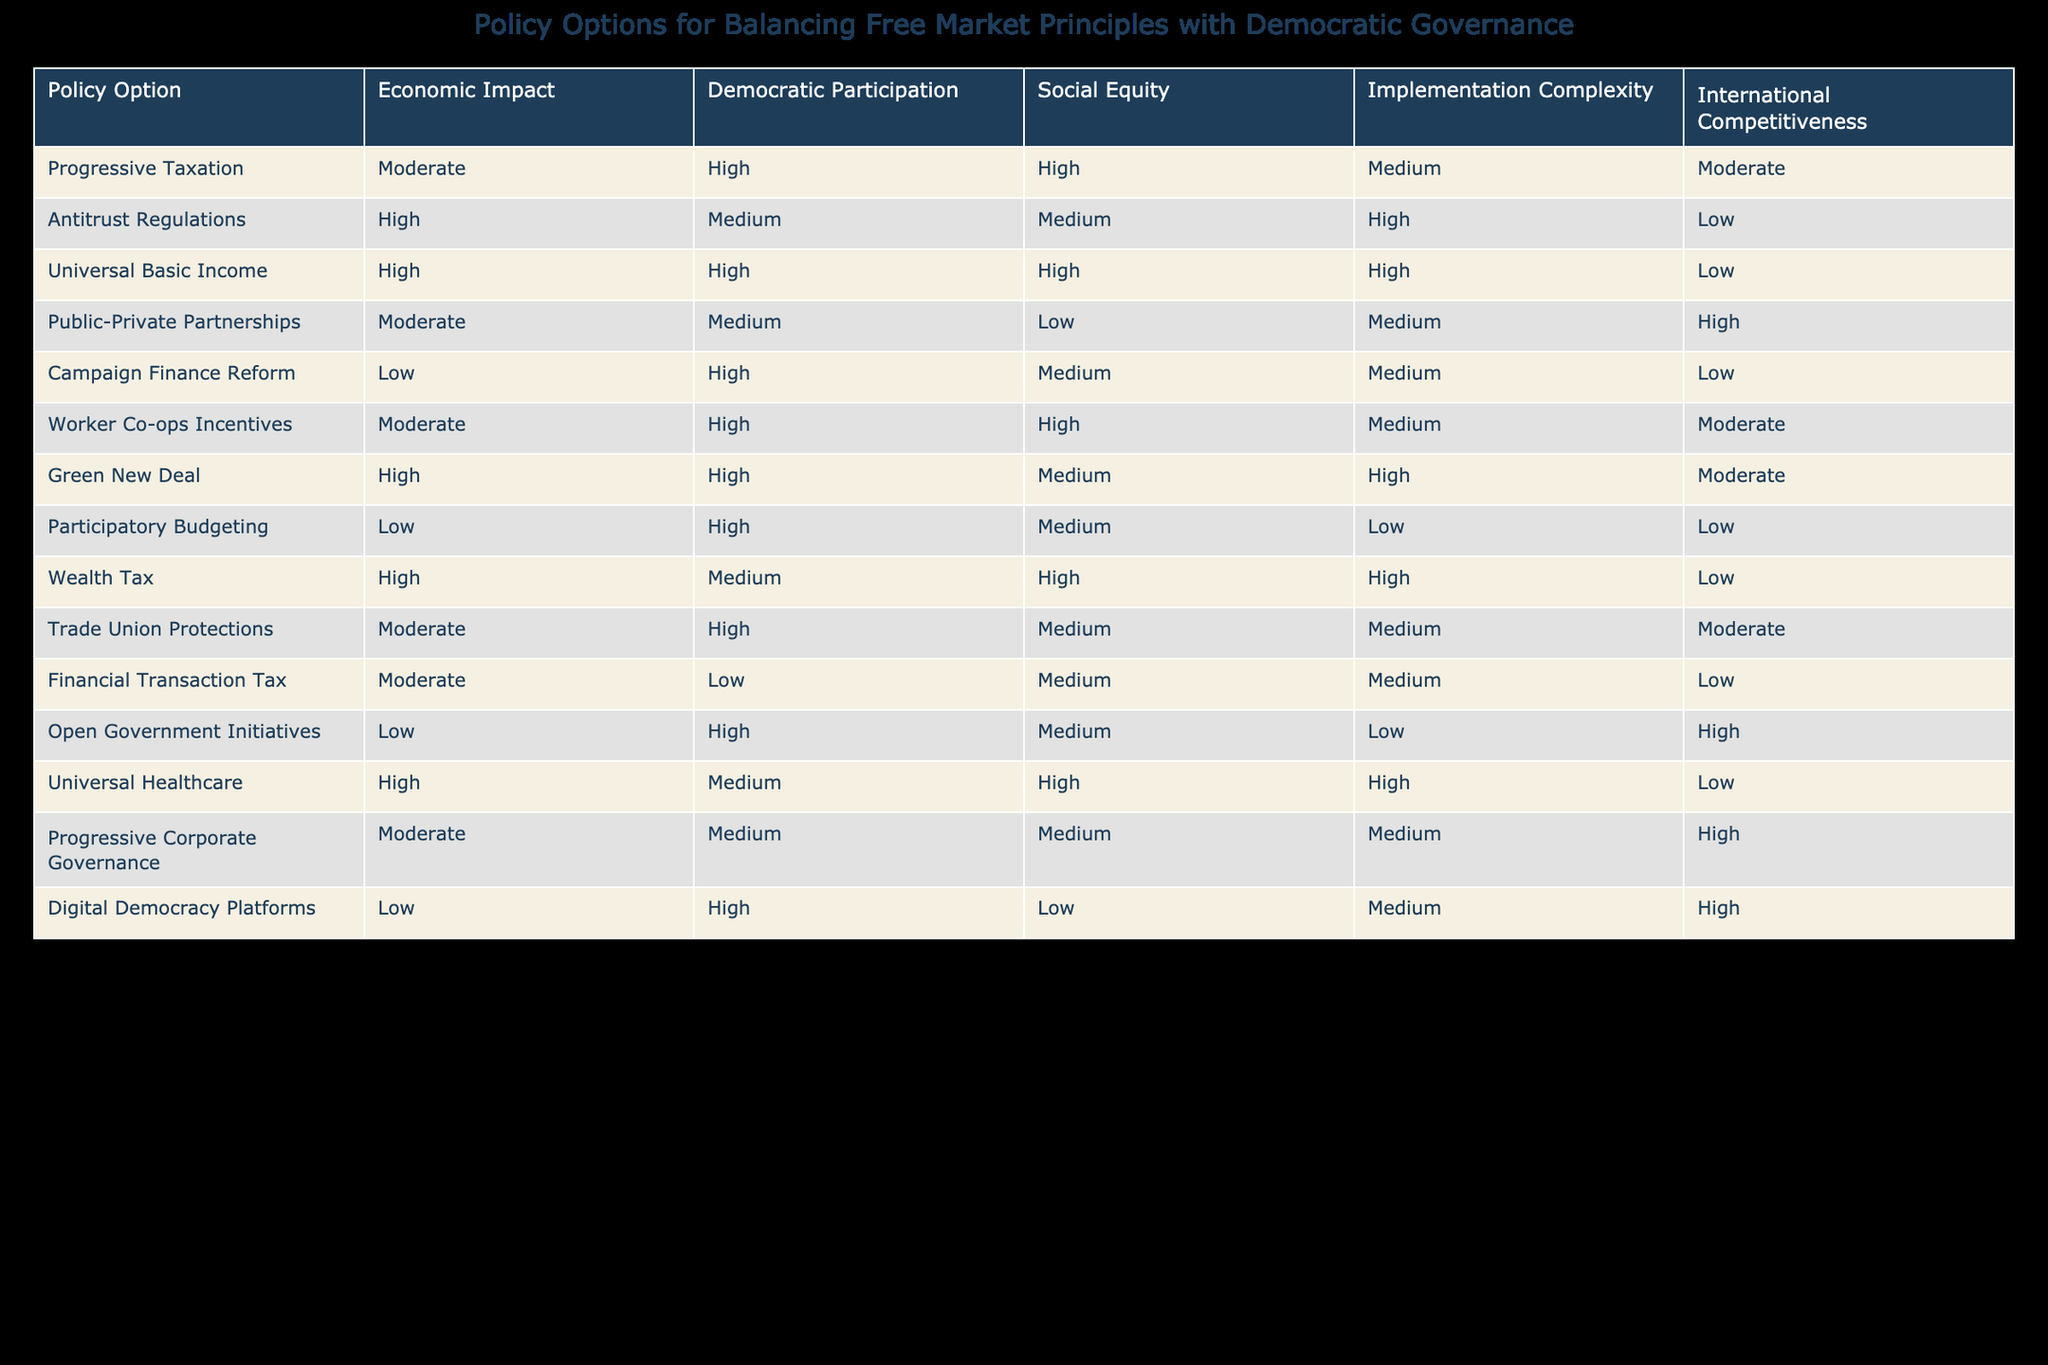What is the economic impact rating for Universal Basic Income? The table shows that the economic impact rating for Universal Basic Income is classified as "High".
Answer: High Which policy options have a high rating for democratic participation? The table lists the policy options with a high rating for democratic participation as "Progressive Taxation", "Universal Basic Income", "Campaign Finance Reform", "Worker Co-ops Incentives", "Green New Deal", "Participatory Budgeting", and "Digital Democracy Platforms".
Answer: Progressive Taxation, Universal Basic Income, Campaign Finance Reform, Worker Co-ops Incentives, Green New Deal, Participatory Budgeting, Digital Democracy Platforms Is it true that all policy options with high social equity ratings also have a high democratic participation rating? To determine this, we will examine the policy options that have high ratings for both social equity and democratic participation. The relevant options are "Universal Basic Income" and "Worker Co-ops Incentives", which both have high ratings in both categories. However, "Progressive Taxation" has a high democratic participation rating but only a moderate social equity rating. Therefore, it is not true that all high social equity ratings also have high democratic participation ratings.
Answer: No What is the average implementation complexity rating for policy options that have a high economic impact? First, we identify the policy options that have a high economic impact, which are "Antitrust Regulations", "Universal Basic Income", "Green New Deal", "Wealth Tax", and "Universal Healthcare". The implementation complexity ratings for these options are High, High, High, High, and High respectively. Since all values are High (numerically represented as high = 3), the total is 3 + 3 + 3 + 3 + 3 = 15. As there are 5 options, the average is 15/5 = 3.
Answer: 3 Which policy option is the least complex to implement among those that enhance international competitiveness? The table indicates that "Antitrust Regulations" has low implementation complexity and among the options enhancing international competitiveness, the options that receive a high rating for international competitiveness are "Public-Private Partnerships" and "Progressive Corporate Governance" and "Digital Democracy Platforms" having moderate to high complexity. Since "Antitrust Regulations" has low complexity, it is the least complex among the international competitive options.
Answer: Antitrust Regulations 